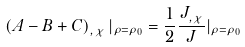<formula> <loc_0><loc_0><loc_500><loc_500>\left ( A - B + C \right ) _ { , \chi } | _ { \rho = \rho _ { 0 } } = \frac { 1 } { 2 } \frac { J _ { , \chi } } { J } | _ { \rho = \rho _ { 0 } }</formula> 